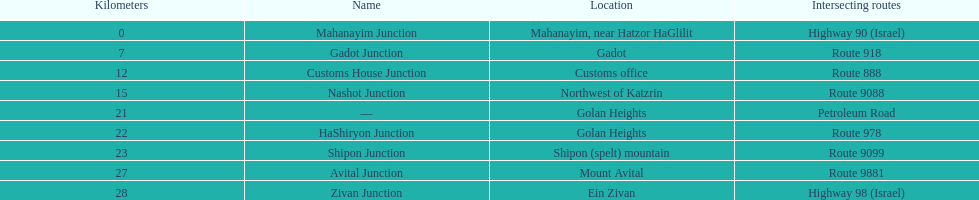Which junction on highway 91 is closer to ein zivan, gadot junction or shipon junction? Gadot Junction. 